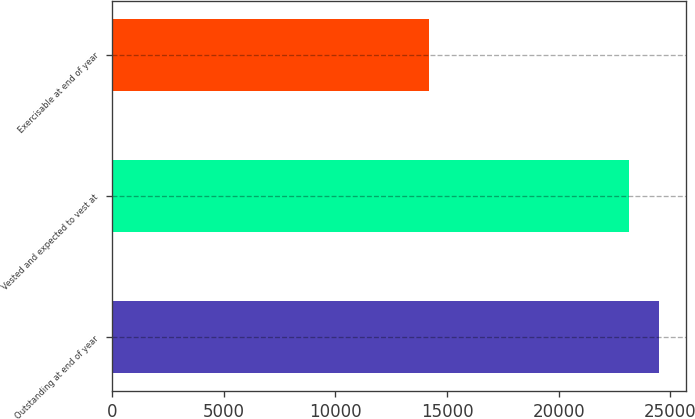<chart> <loc_0><loc_0><loc_500><loc_500><bar_chart><fcel>Outstanding at end of year<fcel>Vested and expected to vest at<fcel>Exercisable at end of year<nl><fcel>24472<fcel>23152<fcel>14174<nl></chart> 